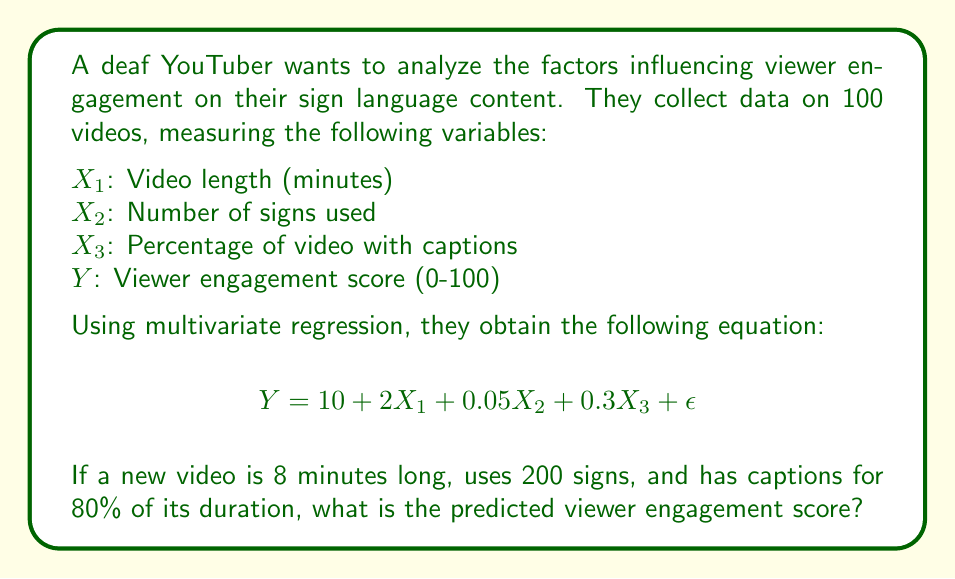Give your solution to this math problem. To solve this problem, we'll follow these steps:

1. Identify the given multivariate regression equation:
   $$Y = 10 + 2X_1 + 0.05X_2 + 0.3X_3 + \epsilon$$

2. Identify the values for each variable in the new video:
   $X_1 = 8$ (video length in minutes)
   $X_2 = 200$ (number of signs used)
   $X_3 = 80$ (percentage of video with captions)

3. Substitute these values into the equation:
   $$Y = 10 + 2(8) + 0.05(200) + 0.3(80) + \epsilon$$

4. Calculate each term:
   $$Y = 10 + 16 + 10 + 24 + \epsilon$$

5. Sum up the terms:
   $$Y = 60 + \epsilon$$

6. Since $\epsilon$ represents the error term and we're calculating the predicted score, we can ignore it for this calculation.

Therefore, the predicted viewer engagement score is 60.
Answer: 60 